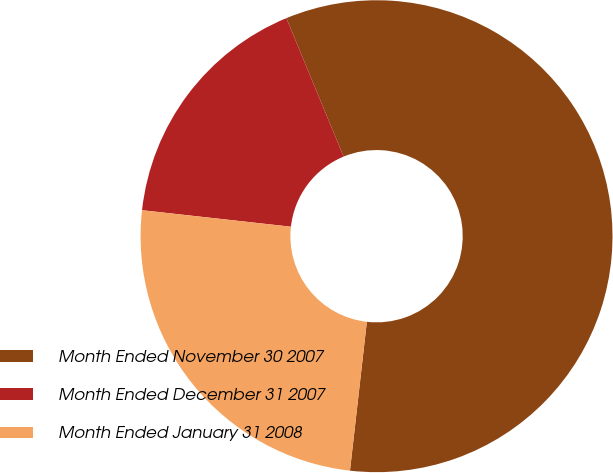Convert chart. <chart><loc_0><loc_0><loc_500><loc_500><pie_chart><fcel>Month Ended November 30 2007<fcel>Month Ended December 31 2007<fcel>Month Ended January 31 2008<nl><fcel>58.04%<fcel>17.0%<fcel>24.96%<nl></chart> 